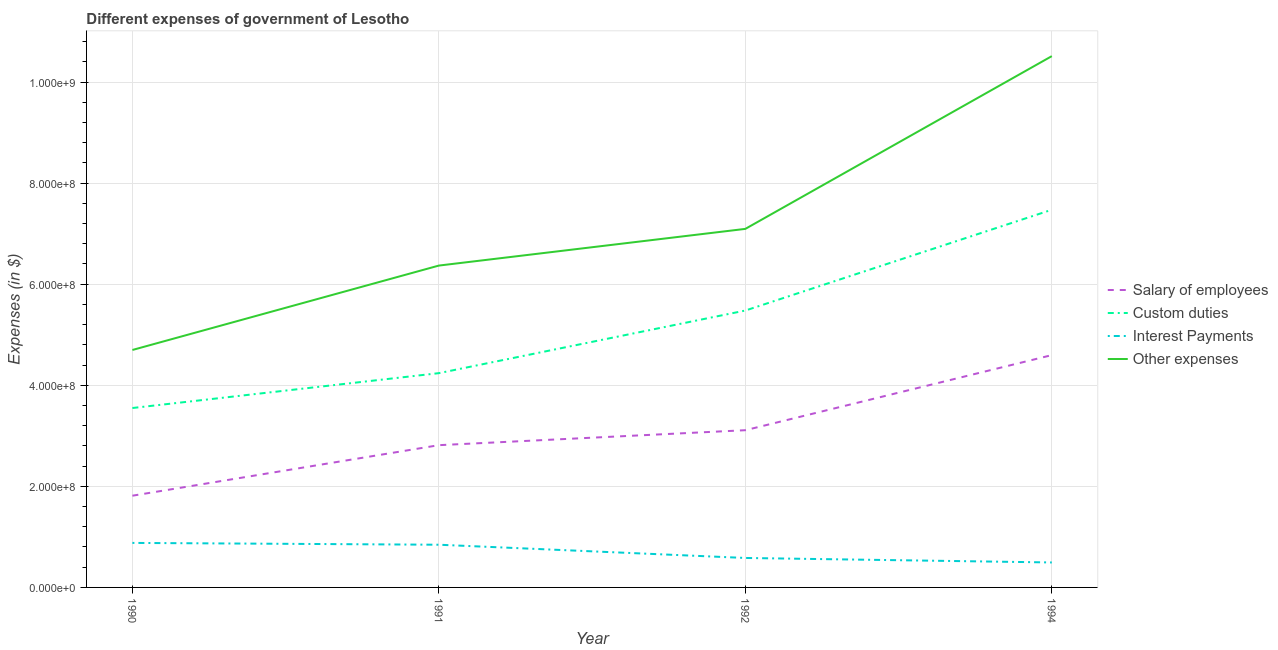What is the amount spent on custom duties in 1990?
Give a very brief answer. 3.55e+08. Across all years, what is the maximum amount spent on interest payments?
Give a very brief answer. 8.81e+07. Across all years, what is the minimum amount spent on salary of employees?
Provide a succinct answer. 1.81e+08. In which year was the amount spent on salary of employees minimum?
Your response must be concise. 1990. What is the total amount spent on custom duties in the graph?
Your response must be concise. 2.07e+09. What is the difference between the amount spent on salary of employees in 1991 and that in 1994?
Your answer should be compact. -1.78e+08. What is the difference between the amount spent on custom duties in 1994 and the amount spent on interest payments in 1990?
Offer a terse response. 6.59e+08. What is the average amount spent on custom duties per year?
Your answer should be very brief. 5.19e+08. In the year 1992, what is the difference between the amount spent on interest payments and amount spent on custom duties?
Give a very brief answer. -4.90e+08. What is the ratio of the amount spent on custom duties in 1991 to that in 1994?
Provide a short and direct response. 0.57. Is the amount spent on salary of employees in 1990 less than that in 1991?
Offer a very short reply. Yes. What is the difference between the highest and the second highest amount spent on other expenses?
Your answer should be very brief. 3.42e+08. What is the difference between the highest and the lowest amount spent on custom duties?
Your answer should be compact. 3.92e+08. Is it the case that in every year, the sum of the amount spent on salary of employees and amount spent on interest payments is greater than the sum of amount spent on custom duties and amount spent on other expenses?
Your response must be concise. No. Is it the case that in every year, the sum of the amount spent on salary of employees and amount spent on custom duties is greater than the amount spent on interest payments?
Give a very brief answer. Yes. Is the amount spent on custom duties strictly less than the amount spent on other expenses over the years?
Offer a very short reply. Yes. How many lines are there?
Offer a terse response. 4. How many years are there in the graph?
Offer a terse response. 4. Are the values on the major ticks of Y-axis written in scientific E-notation?
Your answer should be very brief. Yes. Does the graph contain grids?
Your answer should be very brief. Yes. Where does the legend appear in the graph?
Keep it short and to the point. Center right. How many legend labels are there?
Provide a succinct answer. 4. How are the legend labels stacked?
Ensure brevity in your answer.  Vertical. What is the title of the graph?
Offer a very short reply. Different expenses of government of Lesotho. Does "Macroeconomic management" appear as one of the legend labels in the graph?
Your answer should be compact. No. What is the label or title of the Y-axis?
Give a very brief answer. Expenses (in $). What is the Expenses (in $) of Salary of employees in 1990?
Keep it short and to the point. 1.81e+08. What is the Expenses (in $) in Custom duties in 1990?
Offer a terse response. 3.55e+08. What is the Expenses (in $) in Interest Payments in 1990?
Make the answer very short. 8.81e+07. What is the Expenses (in $) of Other expenses in 1990?
Provide a succinct answer. 4.70e+08. What is the Expenses (in $) of Salary of employees in 1991?
Give a very brief answer. 2.81e+08. What is the Expenses (in $) in Custom duties in 1991?
Give a very brief answer. 4.24e+08. What is the Expenses (in $) in Interest Payments in 1991?
Keep it short and to the point. 8.45e+07. What is the Expenses (in $) of Other expenses in 1991?
Your answer should be compact. 6.37e+08. What is the Expenses (in $) of Salary of employees in 1992?
Your answer should be very brief. 3.11e+08. What is the Expenses (in $) of Custom duties in 1992?
Ensure brevity in your answer.  5.48e+08. What is the Expenses (in $) in Interest Payments in 1992?
Your response must be concise. 5.83e+07. What is the Expenses (in $) of Other expenses in 1992?
Offer a very short reply. 7.09e+08. What is the Expenses (in $) of Salary of employees in 1994?
Provide a succinct answer. 4.60e+08. What is the Expenses (in $) of Custom duties in 1994?
Your answer should be compact. 7.47e+08. What is the Expenses (in $) of Interest Payments in 1994?
Offer a terse response. 4.94e+07. What is the Expenses (in $) of Other expenses in 1994?
Offer a very short reply. 1.05e+09. Across all years, what is the maximum Expenses (in $) of Salary of employees?
Your answer should be compact. 4.60e+08. Across all years, what is the maximum Expenses (in $) of Custom duties?
Provide a short and direct response. 7.47e+08. Across all years, what is the maximum Expenses (in $) in Interest Payments?
Provide a succinct answer. 8.81e+07. Across all years, what is the maximum Expenses (in $) of Other expenses?
Your response must be concise. 1.05e+09. Across all years, what is the minimum Expenses (in $) of Salary of employees?
Your answer should be compact. 1.81e+08. Across all years, what is the minimum Expenses (in $) of Custom duties?
Your response must be concise. 3.55e+08. Across all years, what is the minimum Expenses (in $) in Interest Payments?
Offer a terse response. 4.94e+07. Across all years, what is the minimum Expenses (in $) of Other expenses?
Your answer should be compact. 4.70e+08. What is the total Expenses (in $) in Salary of employees in the graph?
Your answer should be very brief. 1.23e+09. What is the total Expenses (in $) of Custom duties in the graph?
Keep it short and to the point. 2.07e+09. What is the total Expenses (in $) of Interest Payments in the graph?
Ensure brevity in your answer.  2.80e+08. What is the total Expenses (in $) of Other expenses in the graph?
Your answer should be very brief. 2.87e+09. What is the difference between the Expenses (in $) in Salary of employees in 1990 and that in 1991?
Keep it short and to the point. -1.00e+08. What is the difference between the Expenses (in $) of Custom duties in 1990 and that in 1991?
Provide a succinct answer. -6.90e+07. What is the difference between the Expenses (in $) in Interest Payments in 1990 and that in 1991?
Provide a succinct answer. 3.60e+06. What is the difference between the Expenses (in $) in Other expenses in 1990 and that in 1991?
Your answer should be very brief. -1.67e+08. What is the difference between the Expenses (in $) in Salary of employees in 1990 and that in 1992?
Your answer should be compact. -1.30e+08. What is the difference between the Expenses (in $) of Custom duties in 1990 and that in 1992?
Your answer should be very brief. -1.93e+08. What is the difference between the Expenses (in $) in Interest Payments in 1990 and that in 1992?
Keep it short and to the point. 2.98e+07. What is the difference between the Expenses (in $) of Other expenses in 1990 and that in 1992?
Make the answer very short. -2.40e+08. What is the difference between the Expenses (in $) of Salary of employees in 1990 and that in 1994?
Provide a succinct answer. -2.78e+08. What is the difference between the Expenses (in $) of Custom duties in 1990 and that in 1994?
Provide a short and direct response. -3.92e+08. What is the difference between the Expenses (in $) of Interest Payments in 1990 and that in 1994?
Make the answer very short. 3.87e+07. What is the difference between the Expenses (in $) of Other expenses in 1990 and that in 1994?
Your answer should be compact. -5.81e+08. What is the difference between the Expenses (in $) of Salary of employees in 1991 and that in 1992?
Your answer should be compact. -2.96e+07. What is the difference between the Expenses (in $) of Custom duties in 1991 and that in 1992?
Your answer should be very brief. -1.24e+08. What is the difference between the Expenses (in $) in Interest Payments in 1991 and that in 1992?
Make the answer very short. 2.62e+07. What is the difference between the Expenses (in $) of Other expenses in 1991 and that in 1992?
Offer a very short reply. -7.26e+07. What is the difference between the Expenses (in $) of Salary of employees in 1991 and that in 1994?
Give a very brief answer. -1.78e+08. What is the difference between the Expenses (in $) of Custom duties in 1991 and that in 1994?
Ensure brevity in your answer.  -3.23e+08. What is the difference between the Expenses (in $) in Interest Payments in 1991 and that in 1994?
Ensure brevity in your answer.  3.51e+07. What is the difference between the Expenses (in $) of Other expenses in 1991 and that in 1994?
Keep it short and to the point. -4.14e+08. What is the difference between the Expenses (in $) of Salary of employees in 1992 and that in 1994?
Provide a succinct answer. -1.49e+08. What is the difference between the Expenses (in $) in Custom duties in 1992 and that in 1994?
Your answer should be very brief. -1.99e+08. What is the difference between the Expenses (in $) in Interest Payments in 1992 and that in 1994?
Your response must be concise. 8.90e+06. What is the difference between the Expenses (in $) of Other expenses in 1992 and that in 1994?
Your answer should be very brief. -3.42e+08. What is the difference between the Expenses (in $) of Salary of employees in 1990 and the Expenses (in $) of Custom duties in 1991?
Provide a succinct answer. -2.43e+08. What is the difference between the Expenses (in $) in Salary of employees in 1990 and the Expenses (in $) in Interest Payments in 1991?
Ensure brevity in your answer.  9.70e+07. What is the difference between the Expenses (in $) in Salary of employees in 1990 and the Expenses (in $) in Other expenses in 1991?
Offer a very short reply. -4.55e+08. What is the difference between the Expenses (in $) in Custom duties in 1990 and the Expenses (in $) in Interest Payments in 1991?
Your response must be concise. 2.71e+08. What is the difference between the Expenses (in $) in Custom duties in 1990 and the Expenses (in $) in Other expenses in 1991?
Your answer should be compact. -2.82e+08. What is the difference between the Expenses (in $) of Interest Payments in 1990 and the Expenses (in $) of Other expenses in 1991?
Offer a very short reply. -5.49e+08. What is the difference between the Expenses (in $) of Salary of employees in 1990 and the Expenses (in $) of Custom duties in 1992?
Keep it short and to the point. -3.66e+08. What is the difference between the Expenses (in $) of Salary of employees in 1990 and the Expenses (in $) of Interest Payments in 1992?
Keep it short and to the point. 1.23e+08. What is the difference between the Expenses (in $) of Salary of employees in 1990 and the Expenses (in $) of Other expenses in 1992?
Offer a very short reply. -5.28e+08. What is the difference between the Expenses (in $) of Custom duties in 1990 and the Expenses (in $) of Interest Payments in 1992?
Your response must be concise. 2.97e+08. What is the difference between the Expenses (in $) of Custom duties in 1990 and the Expenses (in $) of Other expenses in 1992?
Your answer should be compact. -3.54e+08. What is the difference between the Expenses (in $) of Interest Payments in 1990 and the Expenses (in $) of Other expenses in 1992?
Provide a succinct answer. -6.21e+08. What is the difference between the Expenses (in $) of Salary of employees in 1990 and the Expenses (in $) of Custom duties in 1994?
Ensure brevity in your answer.  -5.66e+08. What is the difference between the Expenses (in $) in Salary of employees in 1990 and the Expenses (in $) in Interest Payments in 1994?
Provide a succinct answer. 1.32e+08. What is the difference between the Expenses (in $) in Salary of employees in 1990 and the Expenses (in $) in Other expenses in 1994?
Offer a very short reply. -8.70e+08. What is the difference between the Expenses (in $) in Custom duties in 1990 and the Expenses (in $) in Interest Payments in 1994?
Keep it short and to the point. 3.06e+08. What is the difference between the Expenses (in $) in Custom duties in 1990 and the Expenses (in $) in Other expenses in 1994?
Keep it short and to the point. -6.96e+08. What is the difference between the Expenses (in $) in Interest Payments in 1990 and the Expenses (in $) in Other expenses in 1994?
Your answer should be compact. -9.63e+08. What is the difference between the Expenses (in $) in Salary of employees in 1991 and the Expenses (in $) in Custom duties in 1992?
Keep it short and to the point. -2.66e+08. What is the difference between the Expenses (in $) in Salary of employees in 1991 and the Expenses (in $) in Interest Payments in 1992?
Provide a short and direct response. 2.23e+08. What is the difference between the Expenses (in $) of Salary of employees in 1991 and the Expenses (in $) of Other expenses in 1992?
Your answer should be very brief. -4.28e+08. What is the difference between the Expenses (in $) of Custom duties in 1991 and the Expenses (in $) of Interest Payments in 1992?
Your answer should be very brief. 3.66e+08. What is the difference between the Expenses (in $) of Custom duties in 1991 and the Expenses (in $) of Other expenses in 1992?
Offer a terse response. -2.85e+08. What is the difference between the Expenses (in $) in Interest Payments in 1991 and the Expenses (in $) in Other expenses in 1992?
Keep it short and to the point. -6.25e+08. What is the difference between the Expenses (in $) in Salary of employees in 1991 and the Expenses (in $) in Custom duties in 1994?
Your answer should be compact. -4.66e+08. What is the difference between the Expenses (in $) in Salary of employees in 1991 and the Expenses (in $) in Interest Payments in 1994?
Your answer should be very brief. 2.32e+08. What is the difference between the Expenses (in $) in Salary of employees in 1991 and the Expenses (in $) in Other expenses in 1994?
Your answer should be compact. -7.70e+08. What is the difference between the Expenses (in $) of Custom duties in 1991 and the Expenses (in $) of Interest Payments in 1994?
Keep it short and to the point. 3.75e+08. What is the difference between the Expenses (in $) in Custom duties in 1991 and the Expenses (in $) in Other expenses in 1994?
Give a very brief answer. -6.27e+08. What is the difference between the Expenses (in $) of Interest Payments in 1991 and the Expenses (in $) of Other expenses in 1994?
Give a very brief answer. -9.67e+08. What is the difference between the Expenses (in $) of Salary of employees in 1992 and the Expenses (in $) of Custom duties in 1994?
Give a very brief answer. -4.36e+08. What is the difference between the Expenses (in $) in Salary of employees in 1992 and the Expenses (in $) in Interest Payments in 1994?
Your response must be concise. 2.62e+08. What is the difference between the Expenses (in $) of Salary of employees in 1992 and the Expenses (in $) of Other expenses in 1994?
Provide a succinct answer. -7.40e+08. What is the difference between the Expenses (in $) of Custom duties in 1992 and the Expenses (in $) of Interest Payments in 1994?
Your answer should be compact. 4.99e+08. What is the difference between the Expenses (in $) in Custom duties in 1992 and the Expenses (in $) in Other expenses in 1994?
Offer a terse response. -5.03e+08. What is the difference between the Expenses (in $) of Interest Payments in 1992 and the Expenses (in $) of Other expenses in 1994?
Provide a short and direct response. -9.93e+08. What is the average Expenses (in $) of Salary of employees per year?
Your answer should be compact. 3.08e+08. What is the average Expenses (in $) in Custom duties per year?
Give a very brief answer. 5.19e+08. What is the average Expenses (in $) in Interest Payments per year?
Ensure brevity in your answer.  7.01e+07. What is the average Expenses (in $) in Other expenses per year?
Keep it short and to the point. 7.17e+08. In the year 1990, what is the difference between the Expenses (in $) in Salary of employees and Expenses (in $) in Custom duties?
Your response must be concise. -1.74e+08. In the year 1990, what is the difference between the Expenses (in $) in Salary of employees and Expenses (in $) in Interest Payments?
Make the answer very short. 9.34e+07. In the year 1990, what is the difference between the Expenses (in $) in Salary of employees and Expenses (in $) in Other expenses?
Your answer should be very brief. -2.88e+08. In the year 1990, what is the difference between the Expenses (in $) of Custom duties and Expenses (in $) of Interest Payments?
Keep it short and to the point. 2.67e+08. In the year 1990, what is the difference between the Expenses (in $) in Custom duties and Expenses (in $) in Other expenses?
Keep it short and to the point. -1.15e+08. In the year 1990, what is the difference between the Expenses (in $) in Interest Payments and Expenses (in $) in Other expenses?
Ensure brevity in your answer.  -3.82e+08. In the year 1991, what is the difference between the Expenses (in $) of Salary of employees and Expenses (in $) of Custom duties?
Make the answer very short. -1.43e+08. In the year 1991, what is the difference between the Expenses (in $) in Salary of employees and Expenses (in $) in Interest Payments?
Provide a succinct answer. 1.97e+08. In the year 1991, what is the difference between the Expenses (in $) of Salary of employees and Expenses (in $) of Other expenses?
Your answer should be very brief. -3.55e+08. In the year 1991, what is the difference between the Expenses (in $) in Custom duties and Expenses (in $) in Interest Payments?
Give a very brief answer. 3.40e+08. In the year 1991, what is the difference between the Expenses (in $) in Custom duties and Expenses (in $) in Other expenses?
Give a very brief answer. -2.13e+08. In the year 1991, what is the difference between the Expenses (in $) in Interest Payments and Expenses (in $) in Other expenses?
Offer a terse response. -5.52e+08. In the year 1992, what is the difference between the Expenses (in $) of Salary of employees and Expenses (in $) of Custom duties?
Keep it short and to the point. -2.37e+08. In the year 1992, what is the difference between the Expenses (in $) in Salary of employees and Expenses (in $) in Interest Payments?
Provide a short and direct response. 2.53e+08. In the year 1992, what is the difference between the Expenses (in $) in Salary of employees and Expenses (in $) in Other expenses?
Keep it short and to the point. -3.98e+08. In the year 1992, what is the difference between the Expenses (in $) of Custom duties and Expenses (in $) of Interest Payments?
Your response must be concise. 4.90e+08. In the year 1992, what is the difference between the Expenses (in $) in Custom duties and Expenses (in $) in Other expenses?
Provide a succinct answer. -1.62e+08. In the year 1992, what is the difference between the Expenses (in $) of Interest Payments and Expenses (in $) of Other expenses?
Offer a very short reply. -6.51e+08. In the year 1994, what is the difference between the Expenses (in $) in Salary of employees and Expenses (in $) in Custom duties?
Your answer should be very brief. -2.88e+08. In the year 1994, what is the difference between the Expenses (in $) in Salary of employees and Expenses (in $) in Interest Payments?
Ensure brevity in your answer.  4.10e+08. In the year 1994, what is the difference between the Expenses (in $) in Salary of employees and Expenses (in $) in Other expenses?
Give a very brief answer. -5.92e+08. In the year 1994, what is the difference between the Expenses (in $) in Custom duties and Expenses (in $) in Interest Payments?
Your answer should be compact. 6.98e+08. In the year 1994, what is the difference between the Expenses (in $) of Custom duties and Expenses (in $) of Other expenses?
Your response must be concise. -3.04e+08. In the year 1994, what is the difference between the Expenses (in $) of Interest Payments and Expenses (in $) of Other expenses?
Provide a succinct answer. -1.00e+09. What is the ratio of the Expenses (in $) of Salary of employees in 1990 to that in 1991?
Ensure brevity in your answer.  0.64. What is the ratio of the Expenses (in $) of Custom duties in 1990 to that in 1991?
Provide a succinct answer. 0.84. What is the ratio of the Expenses (in $) of Interest Payments in 1990 to that in 1991?
Offer a very short reply. 1.04. What is the ratio of the Expenses (in $) in Other expenses in 1990 to that in 1991?
Keep it short and to the point. 0.74. What is the ratio of the Expenses (in $) of Salary of employees in 1990 to that in 1992?
Your answer should be compact. 0.58. What is the ratio of the Expenses (in $) in Custom duties in 1990 to that in 1992?
Provide a succinct answer. 0.65. What is the ratio of the Expenses (in $) in Interest Payments in 1990 to that in 1992?
Provide a succinct answer. 1.51. What is the ratio of the Expenses (in $) of Other expenses in 1990 to that in 1992?
Make the answer very short. 0.66. What is the ratio of the Expenses (in $) of Salary of employees in 1990 to that in 1994?
Your answer should be compact. 0.39. What is the ratio of the Expenses (in $) of Custom duties in 1990 to that in 1994?
Provide a succinct answer. 0.47. What is the ratio of the Expenses (in $) of Interest Payments in 1990 to that in 1994?
Keep it short and to the point. 1.78. What is the ratio of the Expenses (in $) of Other expenses in 1990 to that in 1994?
Your answer should be compact. 0.45. What is the ratio of the Expenses (in $) of Salary of employees in 1991 to that in 1992?
Give a very brief answer. 0.9. What is the ratio of the Expenses (in $) in Custom duties in 1991 to that in 1992?
Your answer should be compact. 0.77. What is the ratio of the Expenses (in $) of Interest Payments in 1991 to that in 1992?
Ensure brevity in your answer.  1.45. What is the ratio of the Expenses (in $) of Other expenses in 1991 to that in 1992?
Give a very brief answer. 0.9. What is the ratio of the Expenses (in $) in Salary of employees in 1991 to that in 1994?
Your answer should be compact. 0.61. What is the ratio of the Expenses (in $) in Custom duties in 1991 to that in 1994?
Keep it short and to the point. 0.57. What is the ratio of the Expenses (in $) of Interest Payments in 1991 to that in 1994?
Your response must be concise. 1.71. What is the ratio of the Expenses (in $) of Other expenses in 1991 to that in 1994?
Offer a very short reply. 0.61. What is the ratio of the Expenses (in $) in Salary of employees in 1992 to that in 1994?
Your response must be concise. 0.68. What is the ratio of the Expenses (in $) of Custom duties in 1992 to that in 1994?
Your answer should be compact. 0.73. What is the ratio of the Expenses (in $) in Interest Payments in 1992 to that in 1994?
Provide a succinct answer. 1.18. What is the ratio of the Expenses (in $) in Other expenses in 1992 to that in 1994?
Provide a short and direct response. 0.67. What is the difference between the highest and the second highest Expenses (in $) of Salary of employees?
Your response must be concise. 1.49e+08. What is the difference between the highest and the second highest Expenses (in $) of Custom duties?
Ensure brevity in your answer.  1.99e+08. What is the difference between the highest and the second highest Expenses (in $) in Interest Payments?
Provide a succinct answer. 3.60e+06. What is the difference between the highest and the second highest Expenses (in $) of Other expenses?
Your response must be concise. 3.42e+08. What is the difference between the highest and the lowest Expenses (in $) in Salary of employees?
Give a very brief answer. 2.78e+08. What is the difference between the highest and the lowest Expenses (in $) in Custom duties?
Ensure brevity in your answer.  3.92e+08. What is the difference between the highest and the lowest Expenses (in $) of Interest Payments?
Your answer should be very brief. 3.87e+07. What is the difference between the highest and the lowest Expenses (in $) of Other expenses?
Your answer should be compact. 5.81e+08. 